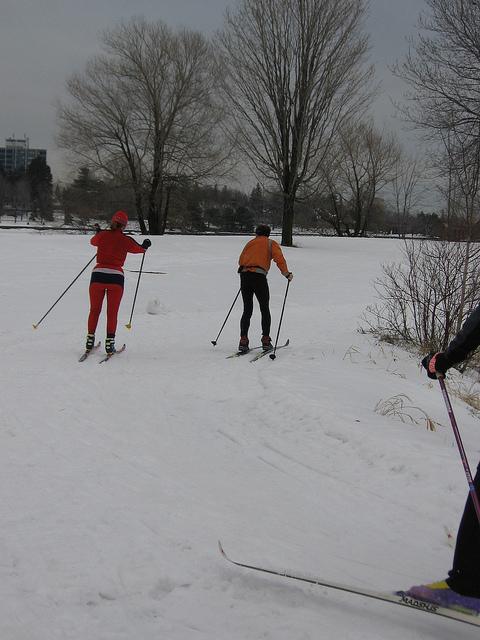How many people are in this photo?
Short answer required. 3. Are the skiing beside each other?
Give a very brief answer. Yes. What sport is this?
Keep it brief. Skiing. How many trees are in the background?
Answer briefly. 3. What does red mean?
Keep it brief. Stop. What color is the sky in this picture?
Short answer required. Gray. 